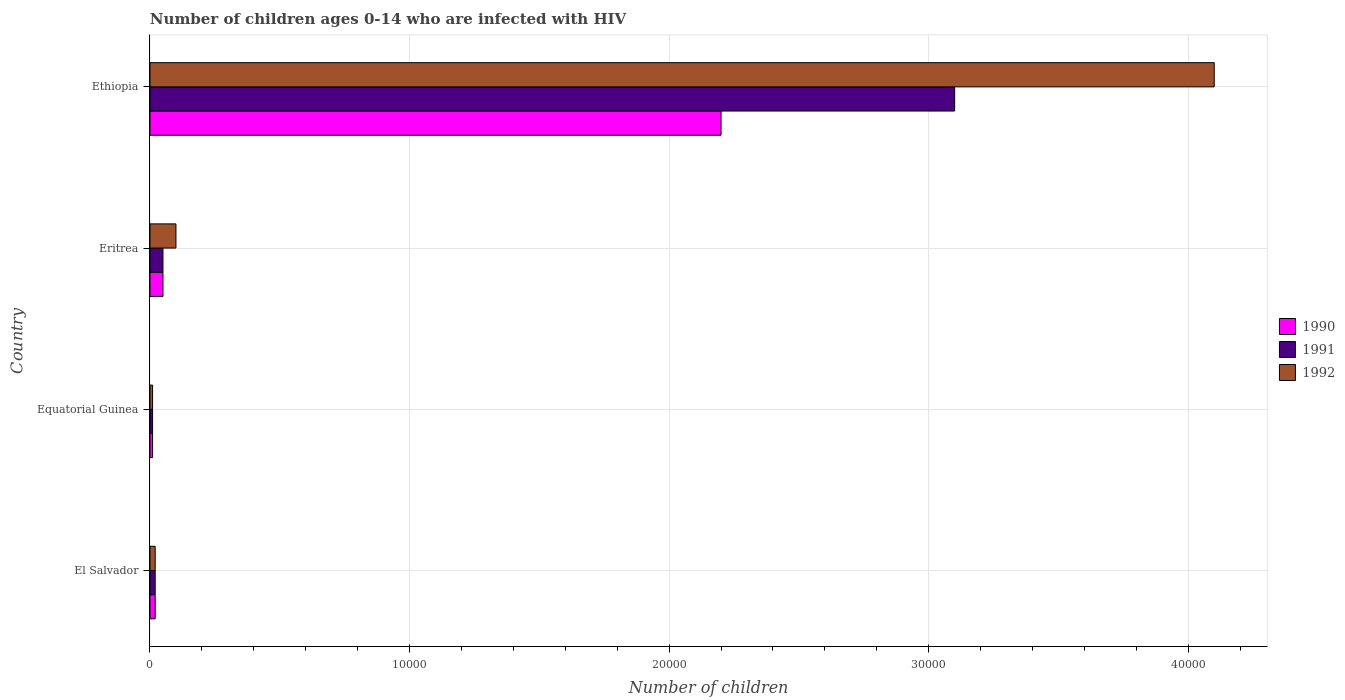How many groups of bars are there?
Your answer should be compact. 4. Are the number of bars on each tick of the Y-axis equal?
Ensure brevity in your answer.  Yes. What is the label of the 3rd group of bars from the top?
Make the answer very short. Equatorial Guinea. What is the number of HIV infected children in 1990 in Eritrea?
Your response must be concise. 500. Across all countries, what is the maximum number of HIV infected children in 1990?
Your answer should be compact. 2.20e+04. Across all countries, what is the minimum number of HIV infected children in 1990?
Make the answer very short. 100. In which country was the number of HIV infected children in 1991 maximum?
Offer a terse response. Ethiopia. In which country was the number of HIV infected children in 1990 minimum?
Provide a succinct answer. Equatorial Guinea. What is the total number of HIV infected children in 1991 in the graph?
Make the answer very short. 3.18e+04. What is the difference between the number of HIV infected children in 1992 in Equatorial Guinea and that in Eritrea?
Your response must be concise. -900. What is the difference between the number of HIV infected children in 1991 in Equatorial Guinea and the number of HIV infected children in 1990 in Eritrea?
Make the answer very short. -400. What is the average number of HIV infected children in 1992 per country?
Make the answer very short. 1.06e+04. What is the difference between the number of HIV infected children in 1992 and number of HIV infected children in 1991 in Ethiopia?
Provide a short and direct response. 10000. What is the ratio of the number of HIV infected children in 1992 in Equatorial Guinea to that in Ethiopia?
Offer a very short reply. 0. What is the difference between the highest and the second highest number of HIV infected children in 1991?
Provide a succinct answer. 3.05e+04. What is the difference between the highest and the lowest number of HIV infected children in 1992?
Your answer should be very brief. 4.09e+04. Is the sum of the number of HIV infected children in 1991 in Equatorial Guinea and Eritrea greater than the maximum number of HIV infected children in 1992 across all countries?
Make the answer very short. No. Is it the case that in every country, the sum of the number of HIV infected children in 1991 and number of HIV infected children in 1992 is greater than the number of HIV infected children in 1990?
Provide a succinct answer. Yes. How many bars are there?
Make the answer very short. 12. Are all the bars in the graph horizontal?
Offer a terse response. Yes. Are the values on the major ticks of X-axis written in scientific E-notation?
Your answer should be compact. No. Does the graph contain any zero values?
Provide a succinct answer. No. Where does the legend appear in the graph?
Your answer should be very brief. Center right. How many legend labels are there?
Provide a short and direct response. 3. What is the title of the graph?
Your answer should be compact. Number of children ages 0-14 who are infected with HIV. Does "1986" appear as one of the legend labels in the graph?
Offer a terse response. No. What is the label or title of the X-axis?
Make the answer very short. Number of children. What is the Number of children in 1991 in El Salvador?
Provide a succinct answer. 200. What is the Number of children in 1992 in El Salvador?
Offer a terse response. 200. What is the Number of children in 1990 in Equatorial Guinea?
Your answer should be very brief. 100. What is the Number of children in 1991 in Eritrea?
Your answer should be very brief. 500. What is the Number of children of 1990 in Ethiopia?
Make the answer very short. 2.20e+04. What is the Number of children of 1991 in Ethiopia?
Your answer should be very brief. 3.10e+04. What is the Number of children of 1992 in Ethiopia?
Make the answer very short. 4.10e+04. Across all countries, what is the maximum Number of children in 1990?
Offer a terse response. 2.20e+04. Across all countries, what is the maximum Number of children of 1991?
Your response must be concise. 3.10e+04. Across all countries, what is the maximum Number of children of 1992?
Your answer should be very brief. 4.10e+04. Across all countries, what is the minimum Number of children of 1990?
Give a very brief answer. 100. Across all countries, what is the minimum Number of children in 1991?
Provide a succinct answer. 100. What is the total Number of children of 1990 in the graph?
Offer a very short reply. 2.28e+04. What is the total Number of children in 1991 in the graph?
Give a very brief answer. 3.18e+04. What is the total Number of children in 1992 in the graph?
Your answer should be compact. 4.23e+04. What is the difference between the Number of children in 1991 in El Salvador and that in Equatorial Guinea?
Your answer should be very brief. 100. What is the difference between the Number of children in 1990 in El Salvador and that in Eritrea?
Give a very brief answer. -300. What is the difference between the Number of children of 1991 in El Salvador and that in Eritrea?
Offer a very short reply. -300. What is the difference between the Number of children in 1992 in El Salvador and that in Eritrea?
Offer a very short reply. -800. What is the difference between the Number of children of 1990 in El Salvador and that in Ethiopia?
Keep it short and to the point. -2.18e+04. What is the difference between the Number of children of 1991 in El Salvador and that in Ethiopia?
Your answer should be compact. -3.08e+04. What is the difference between the Number of children in 1992 in El Salvador and that in Ethiopia?
Provide a succinct answer. -4.08e+04. What is the difference between the Number of children in 1990 in Equatorial Guinea and that in Eritrea?
Provide a short and direct response. -400. What is the difference between the Number of children in 1991 in Equatorial Guinea and that in Eritrea?
Provide a succinct answer. -400. What is the difference between the Number of children in 1992 in Equatorial Guinea and that in Eritrea?
Offer a very short reply. -900. What is the difference between the Number of children of 1990 in Equatorial Guinea and that in Ethiopia?
Make the answer very short. -2.19e+04. What is the difference between the Number of children in 1991 in Equatorial Guinea and that in Ethiopia?
Keep it short and to the point. -3.09e+04. What is the difference between the Number of children of 1992 in Equatorial Guinea and that in Ethiopia?
Make the answer very short. -4.09e+04. What is the difference between the Number of children of 1990 in Eritrea and that in Ethiopia?
Offer a very short reply. -2.15e+04. What is the difference between the Number of children of 1991 in Eritrea and that in Ethiopia?
Your answer should be compact. -3.05e+04. What is the difference between the Number of children in 1992 in Eritrea and that in Ethiopia?
Make the answer very short. -4.00e+04. What is the difference between the Number of children in 1990 in El Salvador and the Number of children in 1991 in Equatorial Guinea?
Your answer should be very brief. 100. What is the difference between the Number of children in 1990 in El Salvador and the Number of children in 1992 in Equatorial Guinea?
Make the answer very short. 100. What is the difference between the Number of children of 1990 in El Salvador and the Number of children of 1991 in Eritrea?
Your response must be concise. -300. What is the difference between the Number of children in 1990 in El Salvador and the Number of children in 1992 in Eritrea?
Your answer should be very brief. -800. What is the difference between the Number of children in 1991 in El Salvador and the Number of children in 1992 in Eritrea?
Keep it short and to the point. -800. What is the difference between the Number of children in 1990 in El Salvador and the Number of children in 1991 in Ethiopia?
Ensure brevity in your answer.  -3.08e+04. What is the difference between the Number of children in 1990 in El Salvador and the Number of children in 1992 in Ethiopia?
Offer a terse response. -4.08e+04. What is the difference between the Number of children of 1991 in El Salvador and the Number of children of 1992 in Ethiopia?
Ensure brevity in your answer.  -4.08e+04. What is the difference between the Number of children of 1990 in Equatorial Guinea and the Number of children of 1991 in Eritrea?
Your answer should be very brief. -400. What is the difference between the Number of children of 1990 in Equatorial Guinea and the Number of children of 1992 in Eritrea?
Provide a short and direct response. -900. What is the difference between the Number of children in 1991 in Equatorial Guinea and the Number of children in 1992 in Eritrea?
Ensure brevity in your answer.  -900. What is the difference between the Number of children in 1990 in Equatorial Guinea and the Number of children in 1991 in Ethiopia?
Keep it short and to the point. -3.09e+04. What is the difference between the Number of children of 1990 in Equatorial Guinea and the Number of children of 1992 in Ethiopia?
Your answer should be very brief. -4.09e+04. What is the difference between the Number of children in 1991 in Equatorial Guinea and the Number of children in 1992 in Ethiopia?
Offer a very short reply. -4.09e+04. What is the difference between the Number of children of 1990 in Eritrea and the Number of children of 1991 in Ethiopia?
Your response must be concise. -3.05e+04. What is the difference between the Number of children in 1990 in Eritrea and the Number of children in 1992 in Ethiopia?
Provide a short and direct response. -4.05e+04. What is the difference between the Number of children of 1991 in Eritrea and the Number of children of 1992 in Ethiopia?
Ensure brevity in your answer.  -4.05e+04. What is the average Number of children of 1990 per country?
Provide a succinct answer. 5700. What is the average Number of children in 1991 per country?
Make the answer very short. 7950. What is the average Number of children of 1992 per country?
Your answer should be compact. 1.06e+04. What is the difference between the Number of children in 1990 and Number of children in 1992 in El Salvador?
Make the answer very short. 0. What is the difference between the Number of children of 1991 and Number of children of 1992 in El Salvador?
Make the answer very short. 0. What is the difference between the Number of children in 1991 and Number of children in 1992 in Equatorial Guinea?
Ensure brevity in your answer.  0. What is the difference between the Number of children in 1990 and Number of children in 1991 in Eritrea?
Provide a short and direct response. 0. What is the difference between the Number of children of 1990 and Number of children of 1992 in Eritrea?
Your response must be concise. -500. What is the difference between the Number of children in 1991 and Number of children in 1992 in Eritrea?
Ensure brevity in your answer.  -500. What is the difference between the Number of children of 1990 and Number of children of 1991 in Ethiopia?
Offer a terse response. -9000. What is the difference between the Number of children of 1990 and Number of children of 1992 in Ethiopia?
Your response must be concise. -1.90e+04. What is the ratio of the Number of children in 1990 in El Salvador to that in Equatorial Guinea?
Your response must be concise. 2. What is the ratio of the Number of children in 1992 in El Salvador to that in Equatorial Guinea?
Keep it short and to the point. 2. What is the ratio of the Number of children of 1991 in El Salvador to that in Eritrea?
Offer a very short reply. 0.4. What is the ratio of the Number of children of 1990 in El Salvador to that in Ethiopia?
Keep it short and to the point. 0.01. What is the ratio of the Number of children of 1991 in El Salvador to that in Ethiopia?
Your response must be concise. 0.01. What is the ratio of the Number of children of 1992 in El Salvador to that in Ethiopia?
Provide a succinct answer. 0. What is the ratio of the Number of children of 1990 in Equatorial Guinea to that in Ethiopia?
Give a very brief answer. 0. What is the ratio of the Number of children of 1991 in Equatorial Guinea to that in Ethiopia?
Provide a succinct answer. 0. What is the ratio of the Number of children of 1992 in Equatorial Guinea to that in Ethiopia?
Give a very brief answer. 0. What is the ratio of the Number of children of 1990 in Eritrea to that in Ethiopia?
Provide a succinct answer. 0.02. What is the ratio of the Number of children of 1991 in Eritrea to that in Ethiopia?
Give a very brief answer. 0.02. What is the ratio of the Number of children in 1992 in Eritrea to that in Ethiopia?
Provide a succinct answer. 0.02. What is the difference between the highest and the second highest Number of children in 1990?
Your response must be concise. 2.15e+04. What is the difference between the highest and the second highest Number of children in 1991?
Offer a very short reply. 3.05e+04. What is the difference between the highest and the second highest Number of children in 1992?
Your answer should be very brief. 4.00e+04. What is the difference between the highest and the lowest Number of children of 1990?
Provide a succinct answer. 2.19e+04. What is the difference between the highest and the lowest Number of children in 1991?
Provide a succinct answer. 3.09e+04. What is the difference between the highest and the lowest Number of children of 1992?
Make the answer very short. 4.09e+04. 